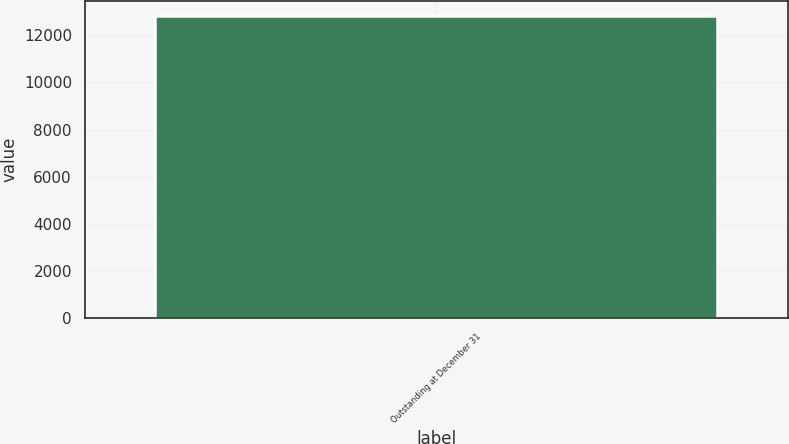Convert chart. <chart><loc_0><loc_0><loc_500><loc_500><bar_chart><fcel>Outstanding at December 31<nl><fcel>12814<nl></chart> 